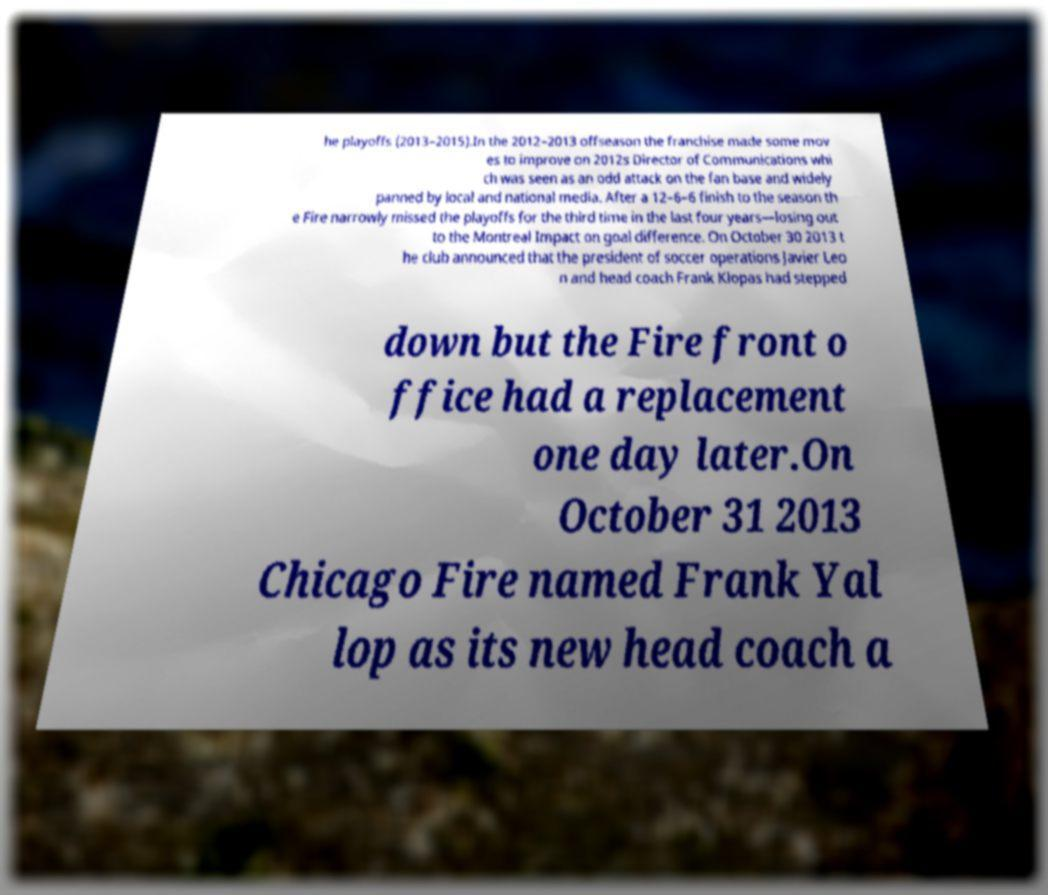What messages or text are displayed in this image? I need them in a readable, typed format. he playoffs (2013–2015).In the 2012–2013 offseason the franchise made some mov es to improve on 2012s Director of Communications whi ch was seen as an odd attack on the fan base and widely panned by local and national media. After a 12–6–6 finish to the season th e Fire narrowly missed the playoffs for the third time in the last four years—losing out to the Montreal Impact on goal difference. On October 30 2013 t he club announced that the president of soccer operations Javier Leo n and head coach Frank Klopas had stepped down but the Fire front o ffice had a replacement one day later.On October 31 2013 Chicago Fire named Frank Yal lop as its new head coach a 